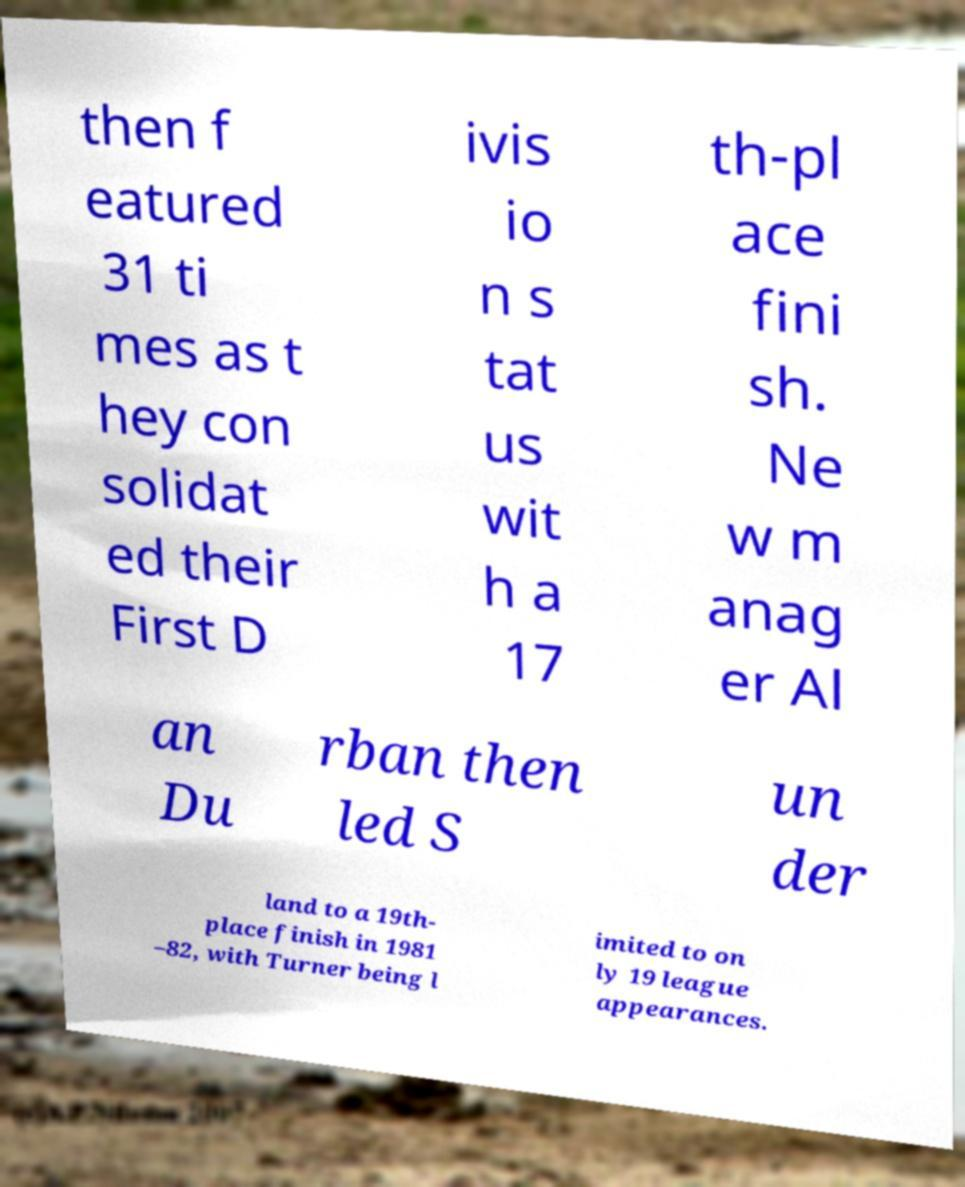Can you read and provide the text displayed in the image?This photo seems to have some interesting text. Can you extract and type it out for me? then f eatured 31 ti mes as t hey con solidat ed their First D ivis io n s tat us wit h a 17 th-pl ace fini sh. Ne w m anag er Al an Du rban then led S un der land to a 19th- place finish in 1981 –82, with Turner being l imited to on ly 19 league appearances. 